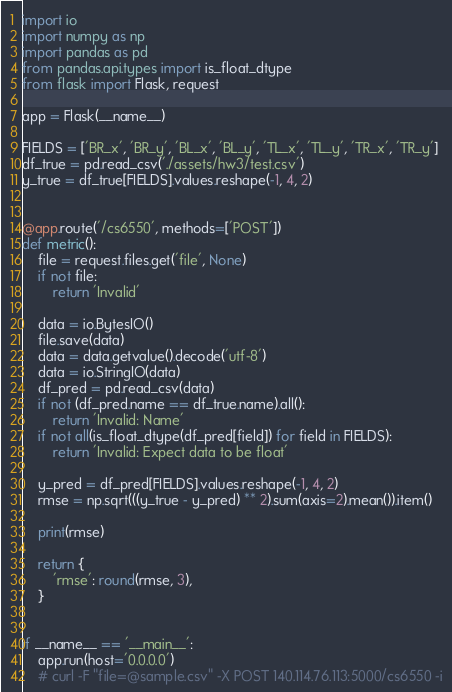<code> <loc_0><loc_0><loc_500><loc_500><_Python_>import io
import numpy as np
import pandas as pd
from pandas.api.types import is_float_dtype
from flask import Flask, request

app = Flask(__name__)

FIELDS = ['BR_x', 'BR_y', 'BL_x', 'BL_y', 'TL_x', 'TL_y', 'TR_x', 'TR_y']
df_true = pd.read_csv('./assets/hw3/test.csv')
y_true = df_true[FIELDS].values.reshape(-1, 4, 2)


@app.route('/cs6550', methods=['POST'])
def metric():
    file = request.files.get('file', None)
    if not file:
        return 'Invalid'

    data = io.BytesIO()
    file.save(data)
    data = data.getvalue().decode('utf-8')
    data = io.StringIO(data)
    df_pred = pd.read_csv(data)
    if not (df_pred.name == df_true.name).all():
        return 'Invalid: Name'
    if not all(is_float_dtype(df_pred[field]) for field in FIELDS):
        return 'Invalid: Expect data to be float'

    y_pred = df_pred[FIELDS].values.reshape(-1, 4, 2)
    rmse = np.sqrt(((y_true - y_pred) ** 2).sum(axis=2).mean()).item()

    print(rmse)

    return {
        'rmse': round(rmse, 3),
    }

    
if __name__ == '__main__':
    app.run(host='0.0.0.0')
    # curl -F "file=@sample.csv" -X POST 140.114.76.113:5000/cs6550 -i
</code> 